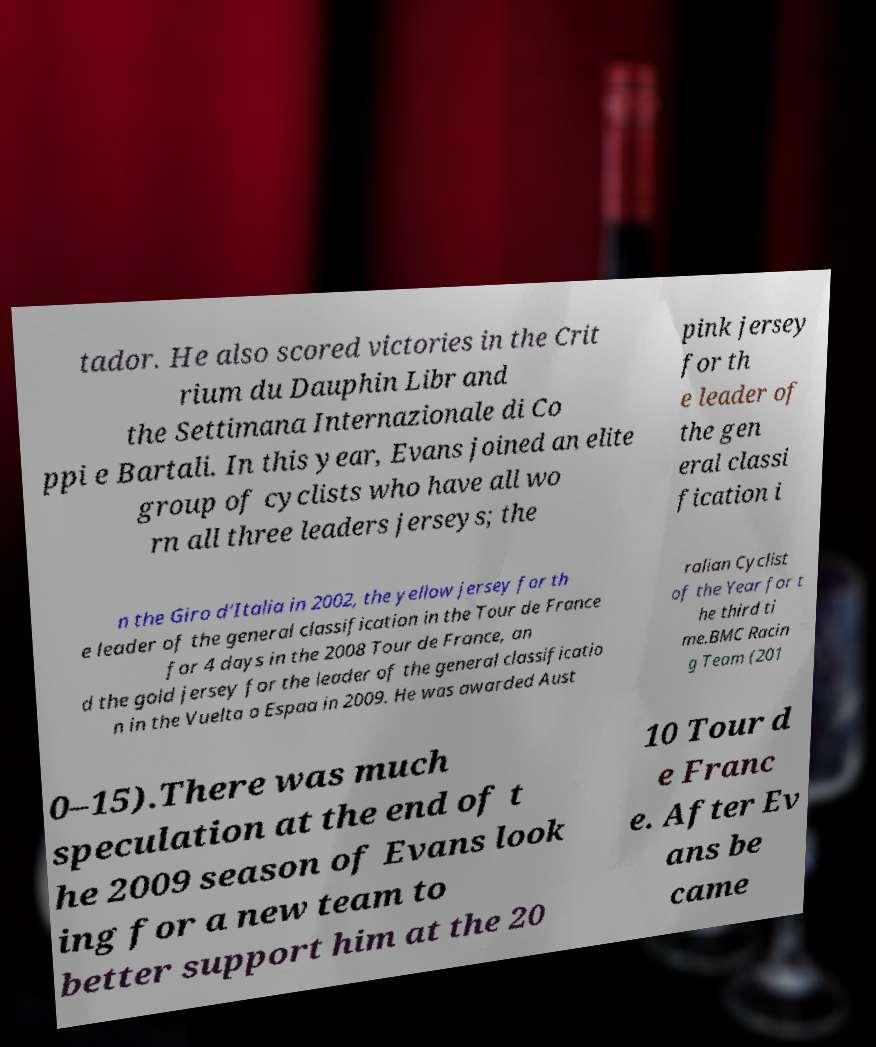Please identify and transcribe the text found in this image. tador. He also scored victories in the Crit rium du Dauphin Libr and the Settimana Internazionale di Co ppi e Bartali. In this year, Evans joined an elite group of cyclists who have all wo rn all three leaders jerseys; the pink jersey for th e leader of the gen eral classi fication i n the Giro d'Italia in 2002, the yellow jersey for th e leader of the general classification in the Tour de France for 4 days in the 2008 Tour de France, an d the gold jersey for the leader of the general classificatio n in the Vuelta a Espaa in 2009. He was awarded Aust ralian Cyclist of the Year for t he third ti me.BMC Racin g Team (201 0–15).There was much speculation at the end of t he 2009 season of Evans look ing for a new team to better support him at the 20 10 Tour d e Franc e. After Ev ans be came 